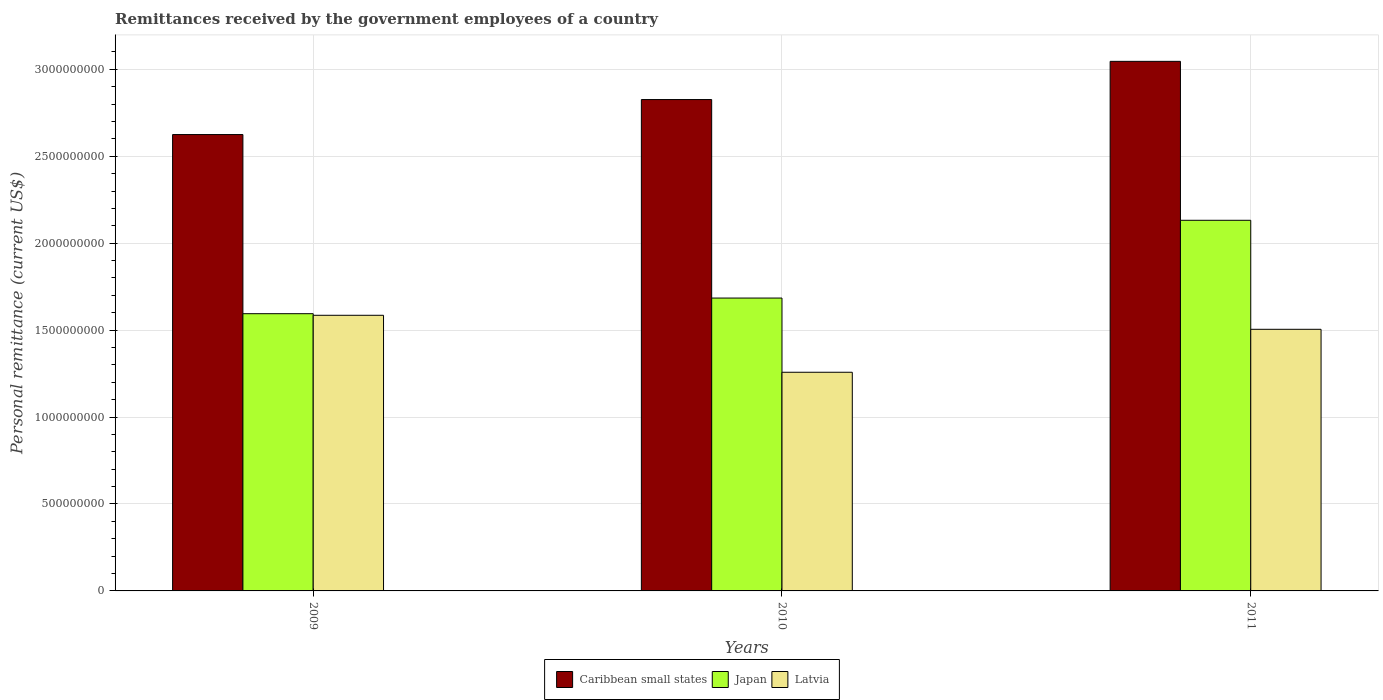Are the number of bars on each tick of the X-axis equal?
Your answer should be compact. Yes. How many bars are there on the 1st tick from the left?
Provide a short and direct response. 3. How many bars are there on the 1st tick from the right?
Your answer should be compact. 3. In how many cases, is the number of bars for a given year not equal to the number of legend labels?
Keep it short and to the point. 0. What is the remittances received by the government employees in Japan in 2011?
Ensure brevity in your answer.  2.13e+09. Across all years, what is the maximum remittances received by the government employees in Caribbean small states?
Keep it short and to the point. 3.05e+09. Across all years, what is the minimum remittances received by the government employees in Latvia?
Provide a short and direct response. 1.26e+09. In which year was the remittances received by the government employees in Japan minimum?
Make the answer very short. 2009. What is the total remittances received by the government employees in Caribbean small states in the graph?
Ensure brevity in your answer.  8.50e+09. What is the difference between the remittances received by the government employees in Japan in 2009 and that in 2010?
Keep it short and to the point. -8.99e+07. What is the difference between the remittances received by the government employees in Latvia in 2010 and the remittances received by the government employees in Japan in 2009?
Provide a succinct answer. -3.37e+08. What is the average remittances received by the government employees in Japan per year?
Provide a short and direct response. 1.80e+09. In the year 2009, what is the difference between the remittances received by the government employees in Caribbean small states and remittances received by the government employees in Latvia?
Provide a succinct answer. 1.04e+09. What is the ratio of the remittances received by the government employees in Japan in 2009 to that in 2011?
Your answer should be very brief. 0.75. Is the difference between the remittances received by the government employees in Caribbean small states in 2010 and 2011 greater than the difference between the remittances received by the government employees in Latvia in 2010 and 2011?
Your response must be concise. Yes. What is the difference between the highest and the second highest remittances received by the government employees in Latvia?
Offer a terse response. 8.06e+07. What is the difference between the highest and the lowest remittances received by the government employees in Latvia?
Provide a short and direct response. 3.28e+08. In how many years, is the remittances received by the government employees in Japan greater than the average remittances received by the government employees in Japan taken over all years?
Provide a succinct answer. 1. What does the 1st bar from the left in 2011 represents?
Your answer should be very brief. Caribbean small states. What does the 3rd bar from the right in 2010 represents?
Offer a terse response. Caribbean small states. How many bars are there?
Your response must be concise. 9. Does the graph contain grids?
Your response must be concise. Yes. How are the legend labels stacked?
Ensure brevity in your answer.  Horizontal. What is the title of the graph?
Your answer should be compact. Remittances received by the government employees of a country. Does "Europe(all income levels)" appear as one of the legend labels in the graph?
Ensure brevity in your answer.  No. What is the label or title of the X-axis?
Your response must be concise. Years. What is the label or title of the Y-axis?
Your answer should be compact. Personal remittance (current US$). What is the Personal remittance (current US$) of Caribbean small states in 2009?
Your response must be concise. 2.62e+09. What is the Personal remittance (current US$) of Japan in 2009?
Offer a very short reply. 1.59e+09. What is the Personal remittance (current US$) of Latvia in 2009?
Offer a very short reply. 1.59e+09. What is the Personal remittance (current US$) of Caribbean small states in 2010?
Offer a very short reply. 2.83e+09. What is the Personal remittance (current US$) of Japan in 2010?
Your answer should be very brief. 1.68e+09. What is the Personal remittance (current US$) of Latvia in 2010?
Provide a succinct answer. 1.26e+09. What is the Personal remittance (current US$) of Caribbean small states in 2011?
Keep it short and to the point. 3.05e+09. What is the Personal remittance (current US$) in Japan in 2011?
Your response must be concise. 2.13e+09. What is the Personal remittance (current US$) of Latvia in 2011?
Offer a terse response. 1.50e+09. Across all years, what is the maximum Personal remittance (current US$) in Caribbean small states?
Your answer should be compact. 3.05e+09. Across all years, what is the maximum Personal remittance (current US$) of Japan?
Offer a terse response. 2.13e+09. Across all years, what is the maximum Personal remittance (current US$) in Latvia?
Your response must be concise. 1.59e+09. Across all years, what is the minimum Personal remittance (current US$) of Caribbean small states?
Your response must be concise. 2.62e+09. Across all years, what is the minimum Personal remittance (current US$) in Japan?
Provide a short and direct response. 1.59e+09. Across all years, what is the minimum Personal remittance (current US$) of Latvia?
Give a very brief answer. 1.26e+09. What is the total Personal remittance (current US$) in Caribbean small states in the graph?
Offer a very short reply. 8.50e+09. What is the total Personal remittance (current US$) in Japan in the graph?
Make the answer very short. 5.41e+09. What is the total Personal remittance (current US$) of Latvia in the graph?
Keep it short and to the point. 4.35e+09. What is the difference between the Personal remittance (current US$) in Caribbean small states in 2009 and that in 2010?
Your answer should be very brief. -2.01e+08. What is the difference between the Personal remittance (current US$) in Japan in 2009 and that in 2010?
Provide a succinct answer. -8.99e+07. What is the difference between the Personal remittance (current US$) in Latvia in 2009 and that in 2010?
Your response must be concise. 3.28e+08. What is the difference between the Personal remittance (current US$) of Caribbean small states in 2009 and that in 2011?
Provide a succinct answer. -4.21e+08. What is the difference between the Personal remittance (current US$) of Japan in 2009 and that in 2011?
Make the answer very short. -5.37e+08. What is the difference between the Personal remittance (current US$) of Latvia in 2009 and that in 2011?
Offer a terse response. 8.06e+07. What is the difference between the Personal remittance (current US$) of Caribbean small states in 2010 and that in 2011?
Offer a very short reply. -2.20e+08. What is the difference between the Personal remittance (current US$) of Japan in 2010 and that in 2011?
Give a very brief answer. -4.47e+08. What is the difference between the Personal remittance (current US$) of Latvia in 2010 and that in 2011?
Give a very brief answer. -2.47e+08. What is the difference between the Personal remittance (current US$) of Caribbean small states in 2009 and the Personal remittance (current US$) of Japan in 2010?
Give a very brief answer. 9.40e+08. What is the difference between the Personal remittance (current US$) of Caribbean small states in 2009 and the Personal remittance (current US$) of Latvia in 2010?
Offer a terse response. 1.37e+09. What is the difference between the Personal remittance (current US$) of Japan in 2009 and the Personal remittance (current US$) of Latvia in 2010?
Your answer should be very brief. 3.37e+08. What is the difference between the Personal remittance (current US$) in Caribbean small states in 2009 and the Personal remittance (current US$) in Japan in 2011?
Provide a short and direct response. 4.93e+08. What is the difference between the Personal remittance (current US$) of Caribbean small states in 2009 and the Personal remittance (current US$) of Latvia in 2011?
Provide a short and direct response. 1.12e+09. What is the difference between the Personal remittance (current US$) in Japan in 2009 and the Personal remittance (current US$) in Latvia in 2011?
Provide a short and direct response. 8.98e+07. What is the difference between the Personal remittance (current US$) of Caribbean small states in 2010 and the Personal remittance (current US$) of Japan in 2011?
Make the answer very short. 6.94e+08. What is the difference between the Personal remittance (current US$) of Caribbean small states in 2010 and the Personal remittance (current US$) of Latvia in 2011?
Your answer should be compact. 1.32e+09. What is the difference between the Personal remittance (current US$) in Japan in 2010 and the Personal remittance (current US$) in Latvia in 2011?
Ensure brevity in your answer.  1.80e+08. What is the average Personal remittance (current US$) of Caribbean small states per year?
Offer a very short reply. 2.83e+09. What is the average Personal remittance (current US$) of Japan per year?
Make the answer very short. 1.80e+09. What is the average Personal remittance (current US$) of Latvia per year?
Your answer should be compact. 1.45e+09. In the year 2009, what is the difference between the Personal remittance (current US$) of Caribbean small states and Personal remittance (current US$) of Japan?
Make the answer very short. 1.03e+09. In the year 2009, what is the difference between the Personal remittance (current US$) of Caribbean small states and Personal remittance (current US$) of Latvia?
Make the answer very short. 1.04e+09. In the year 2009, what is the difference between the Personal remittance (current US$) of Japan and Personal remittance (current US$) of Latvia?
Keep it short and to the point. 9.21e+06. In the year 2010, what is the difference between the Personal remittance (current US$) of Caribbean small states and Personal remittance (current US$) of Japan?
Your response must be concise. 1.14e+09. In the year 2010, what is the difference between the Personal remittance (current US$) in Caribbean small states and Personal remittance (current US$) in Latvia?
Keep it short and to the point. 1.57e+09. In the year 2010, what is the difference between the Personal remittance (current US$) in Japan and Personal remittance (current US$) in Latvia?
Make the answer very short. 4.27e+08. In the year 2011, what is the difference between the Personal remittance (current US$) of Caribbean small states and Personal remittance (current US$) of Japan?
Offer a very short reply. 9.14e+08. In the year 2011, what is the difference between the Personal remittance (current US$) of Caribbean small states and Personal remittance (current US$) of Latvia?
Your answer should be compact. 1.54e+09. In the year 2011, what is the difference between the Personal remittance (current US$) of Japan and Personal remittance (current US$) of Latvia?
Provide a short and direct response. 6.27e+08. What is the ratio of the Personal remittance (current US$) in Caribbean small states in 2009 to that in 2010?
Offer a terse response. 0.93. What is the ratio of the Personal remittance (current US$) of Japan in 2009 to that in 2010?
Offer a very short reply. 0.95. What is the ratio of the Personal remittance (current US$) of Latvia in 2009 to that in 2010?
Make the answer very short. 1.26. What is the ratio of the Personal remittance (current US$) in Caribbean small states in 2009 to that in 2011?
Your answer should be compact. 0.86. What is the ratio of the Personal remittance (current US$) of Japan in 2009 to that in 2011?
Give a very brief answer. 0.75. What is the ratio of the Personal remittance (current US$) in Latvia in 2009 to that in 2011?
Your answer should be very brief. 1.05. What is the ratio of the Personal remittance (current US$) of Caribbean small states in 2010 to that in 2011?
Provide a short and direct response. 0.93. What is the ratio of the Personal remittance (current US$) in Japan in 2010 to that in 2011?
Your answer should be compact. 0.79. What is the ratio of the Personal remittance (current US$) of Latvia in 2010 to that in 2011?
Make the answer very short. 0.84. What is the difference between the highest and the second highest Personal remittance (current US$) of Caribbean small states?
Your answer should be compact. 2.20e+08. What is the difference between the highest and the second highest Personal remittance (current US$) of Japan?
Provide a short and direct response. 4.47e+08. What is the difference between the highest and the second highest Personal remittance (current US$) in Latvia?
Offer a terse response. 8.06e+07. What is the difference between the highest and the lowest Personal remittance (current US$) in Caribbean small states?
Your answer should be very brief. 4.21e+08. What is the difference between the highest and the lowest Personal remittance (current US$) in Japan?
Offer a very short reply. 5.37e+08. What is the difference between the highest and the lowest Personal remittance (current US$) in Latvia?
Keep it short and to the point. 3.28e+08. 